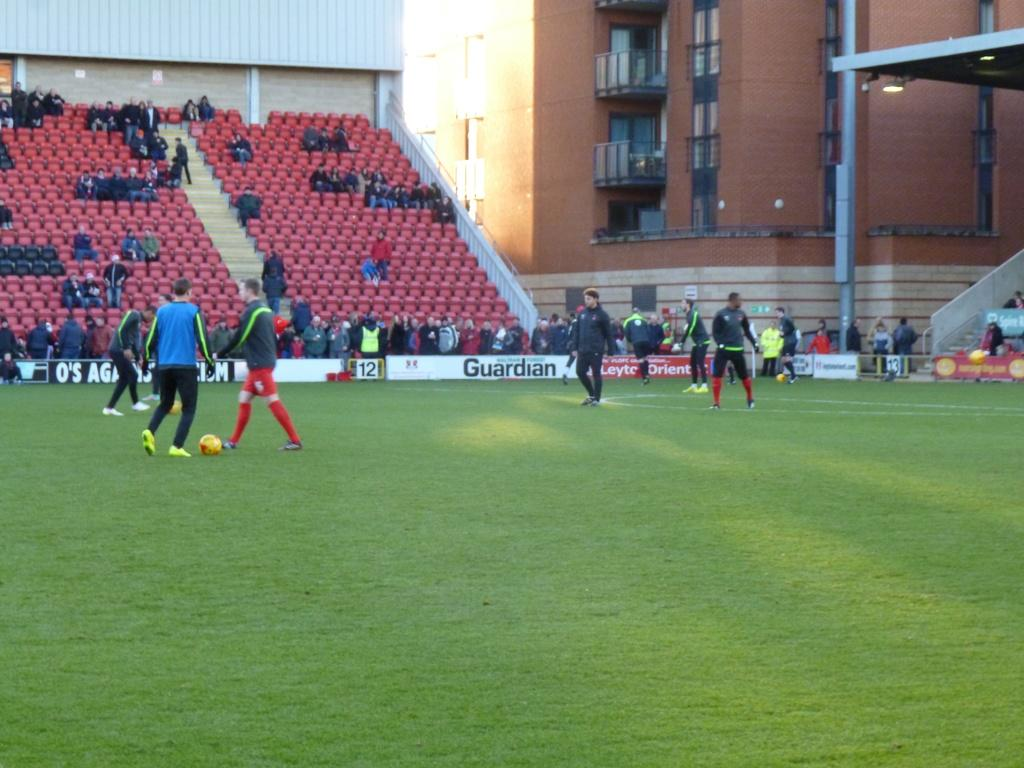<image>
Relay a brief, clear account of the picture shown. Soccer field with players standing in front of a Guardian sign 